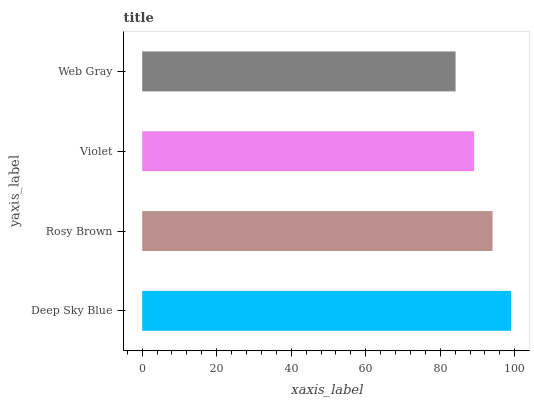Is Web Gray the minimum?
Answer yes or no. Yes. Is Deep Sky Blue the maximum?
Answer yes or no. Yes. Is Rosy Brown the minimum?
Answer yes or no. No. Is Rosy Brown the maximum?
Answer yes or no. No. Is Deep Sky Blue greater than Rosy Brown?
Answer yes or no. Yes. Is Rosy Brown less than Deep Sky Blue?
Answer yes or no. Yes. Is Rosy Brown greater than Deep Sky Blue?
Answer yes or no. No. Is Deep Sky Blue less than Rosy Brown?
Answer yes or no. No. Is Rosy Brown the high median?
Answer yes or no. Yes. Is Violet the low median?
Answer yes or no. Yes. Is Deep Sky Blue the high median?
Answer yes or no. No. Is Rosy Brown the low median?
Answer yes or no. No. 